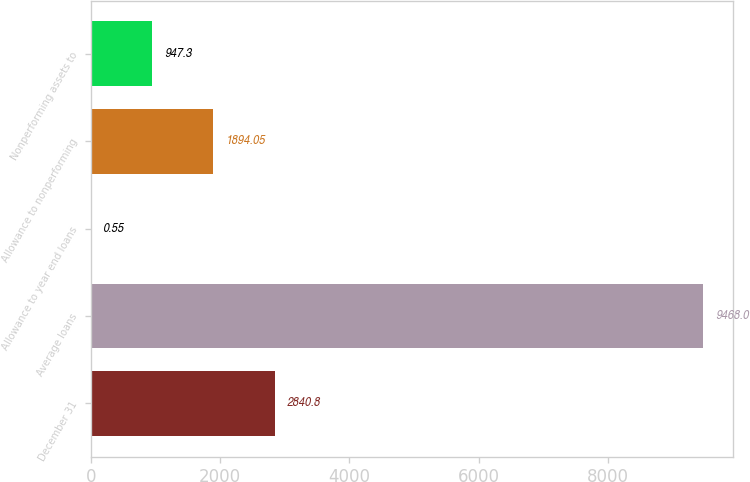Convert chart to OTSL. <chart><loc_0><loc_0><loc_500><loc_500><bar_chart><fcel>December 31<fcel>Average loans<fcel>Allowance to year end loans<fcel>Allowance to nonperforming<fcel>Nonperforming assets to<nl><fcel>2840.8<fcel>9468<fcel>0.55<fcel>1894.05<fcel>947.3<nl></chart> 